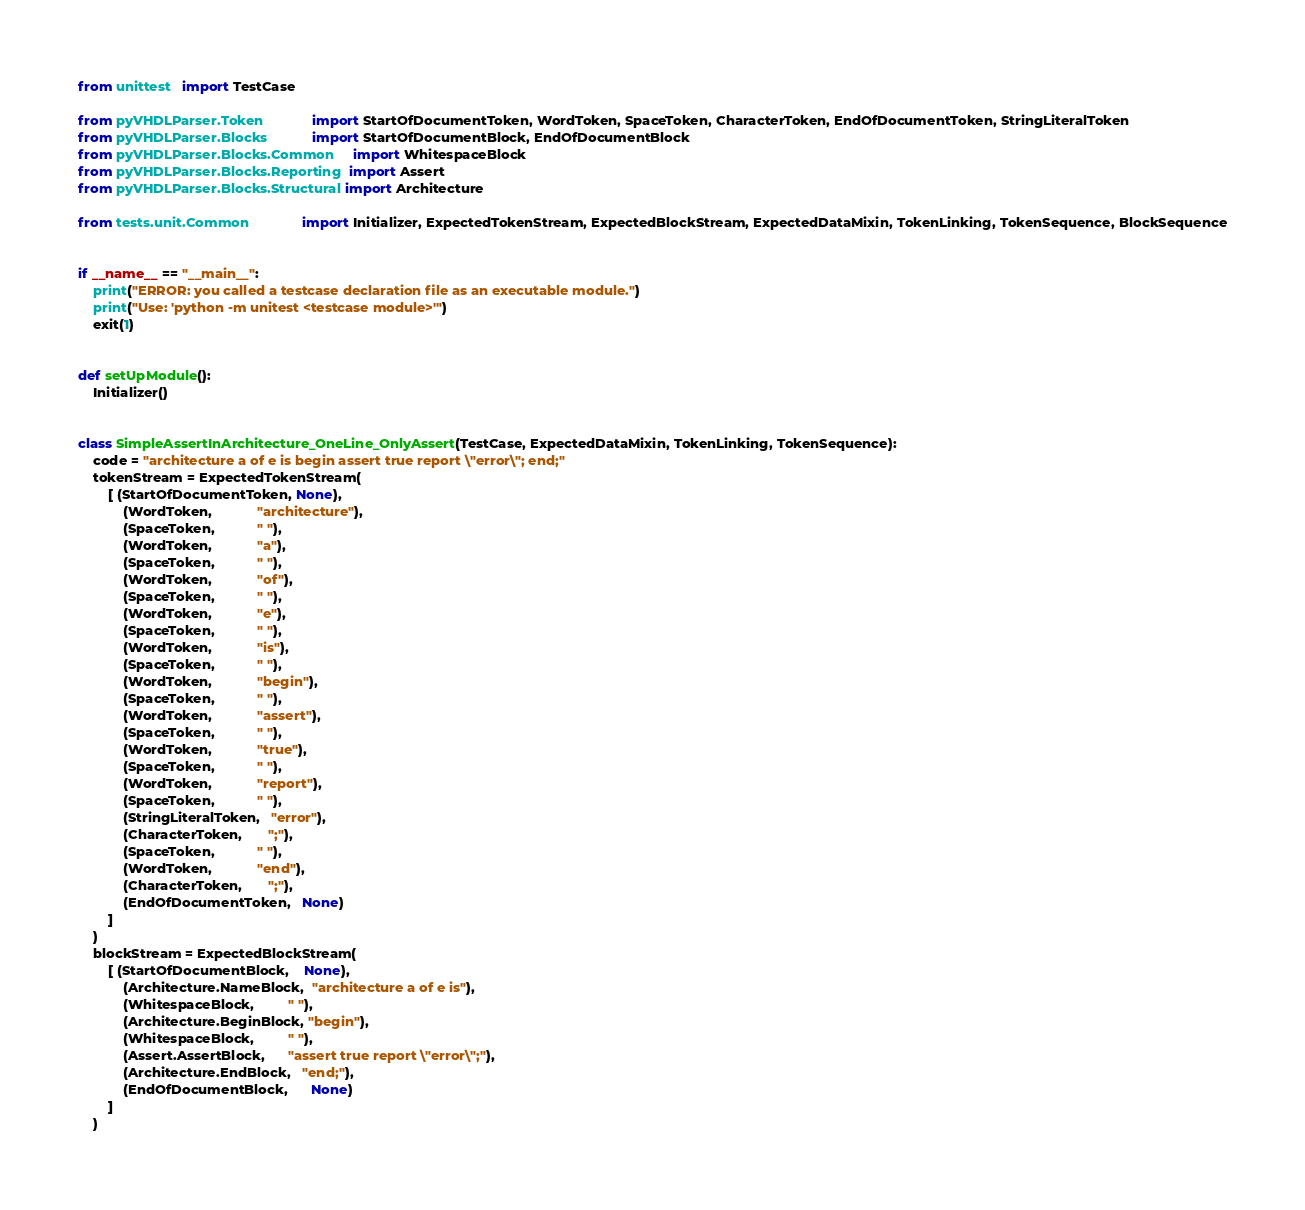Convert code to text. <code><loc_0><loc_0><loc_500><loc_500><_Python_>from unittest   import TestCase

from pyVHDLParser.Token             import StartOfDocumentToken, WordToken, SpaceToken, CharacterToken, EndOfDocumentToken, StringLiteralToken
from pyVHDLParser.Blocks            import StartOfDocumentBlock, EndOfDocumentBlock
from pyVHDLParser.Blocks.Common     import WhitespaceBlock
from pyVHDLParser.Blocks.Reporting  import Assert
from pyVHDLParser.Blocks.Structural import Architecture

from tests.unit.Common              import Initializer, ExpectedTokenStream, ExpectedBlockStream, ExpectedDataMixin, TokenLinking, TokenSequence, BlockSequence


if __name__ == "__main__":
	print("ERROR: you called a testcase declaration file as an executable module.")
	print("Use: 'python -m unitest <testcase module>'")
	exit(1)


def setUpModule():
	Initializer()


class SimpleAssertInArchitecture_OneLine_OnlyAssert(TestCase, ExpectedDataMixin, TokenLinking, TokenSequence):
	code = "architecture a of e is begin assert true report \"error\"; end;"
	tokenStream = ExpectedTokenStream(
		[ (StartOfDocumentToken, None),
			(WordToken,            "architecture"),
			(SpaceToken,           " "),
			(WordToken,            "a"),
			(SpaceToken,           " "),
			(WordToken,            "of"),
			(SpaceToken,           " "),
			(WordToken,            "e"),
			(SpaceToken,           " "),
			(WordToken,            "is"),
			(SpaceToken,           " "),
			(WordToken,            "begin"),
			(SpaceToken,           " "),
			(WordToken,            "assert"),
			(SpaceToken,           " "),
			(WordToken,            "true"),
			(SpaceToken,           " "),
			(WordToken,            "report"),
			(SpaceToken,           " "),
			(StringLiteralToken,   "error"),
			(CharacterToken,       ";"),
			(SpaceToken,           " "),
			(WordToken,            "end"),
			(CharacterToken,       ";"),
			(EndOfDocumentToken,   None)
		]
	)
	blockStream = ExpectedBlockStream(
		[ (StartOfDocumentBlock,    None),
			(Architecture.NameBlock,  "architecture a of e is"),
			(WhitespaceBlock,         " "),
			(Architecture.BeginBlock, "begin"),
			(WhitespaceBlock,         " "),
			(Assert.AssertBlock,      "assert true report \"error\";"),
			(Architecture.EndBlock,   "end;"),
			(EndOfDocumentBlock,      None)
		]
	)
</code> 